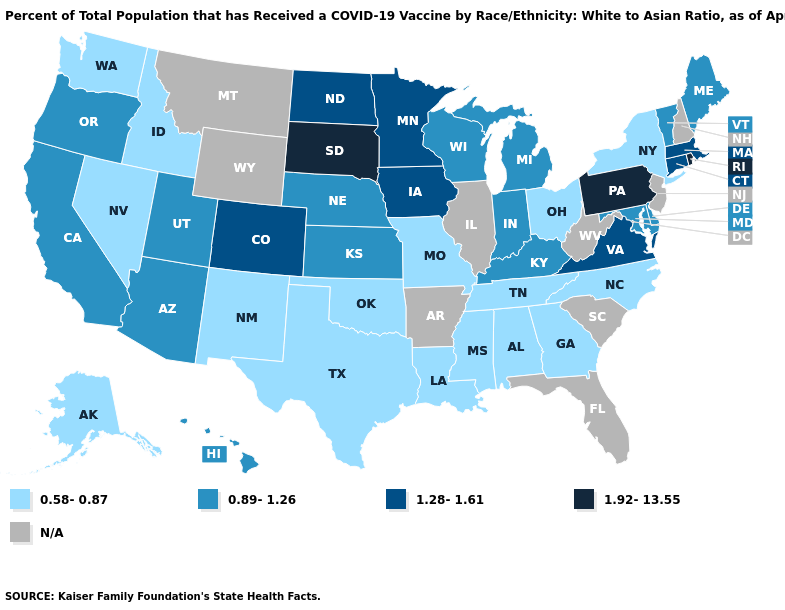Which states hav the highest value in the Northeast?
Answer briefly. Pennsylvania, Rhode Island. Name the states that have a value in the range N/A?
Give a very brief answer. Arkansas, Florida, Illinois, Montana, New Hampshire, New Jersey, South Carolina, West Virginia, Wyoming. Name the states that have a value in the range 1.28-1.61?
Concise answer only. Colorado, Connecticut, Iowa, Massachusetts, Minnesota, North Dakota, Virginia. What is the value of Wyoming?
Short answer required. N/A. Name the states that have a value in the range 0.58-0.87?
Write a very short answer. Alabama, Alaska, Georgia, Idaho, Louisiana, Mississippi, Missouri, Nevada, New Mexico, New York, North Carolina, Ohio, Oklahoma, Tennessee, Texas, Washington. What is the lowest value in the USA?
Concise answer only. 0.58-0.87. Name the states that have a value in the range 0.89-1.26?
Be succinct. Arizona, California, Delaware, Hawaii, Indiana, Kansas, Kentucky, Maine, Maryland, Michigan, Nebraska, Oregon, Utah, Vermont, Wisconsin. What is the value of Nebraska?
Be succinct. 0.89-1.26. Does Tennessee have the lowest value in the South?
Keep it brief. Yes. What is the value of Utah?
Be succinct. 0.89-1.26. Among the states that border West Virginia , which have the lowest value?
Be succinct. Ohio. What is the value of California?
Keep it brief. 0.89-1.26. 